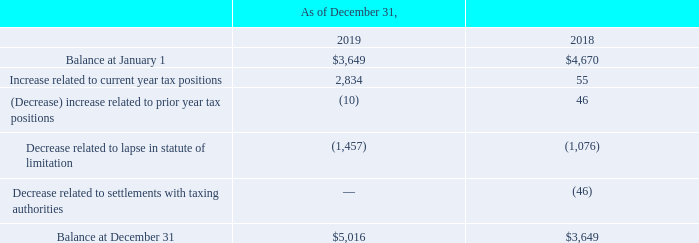NOTES TO CONSOLIDATED FINANCIAL STATEMENTS (in thousands, except for share and per share data)
Following the enactment of the 2017 Tax Cut and Jobs Act and the associated one-time transition tax, in general, repatriation of foreign earnings to the US can be completed with no incremental US Tax. However, there are limited other taxes that continue to apply such as foreign withholding and certain state taxes. The company records a deferred tax liability for the estimated foreign earnings and state tax cost associated with the undistributed foreign earnings that are not permanently reinvested.
The Tax Act also includes provisions for Global Intangible Low-Taxed Income (“GILTI”) wherein taxes on foreign income are imposed in excess of a deemed return on tangible assets of foreign corporations. We elected to recognize the tax on GILTI as an expense in the period the tax is incurred.
We recognize the financial statement benefit of a tax position when it is more-likely-than-not, based on its technical merits, that the position will be sustained upon examination. A tax position that meets the more-likely-than-not threshold is then measured to determine the amount of benefit to be recognized in the financial statements. As of December 31, 2019, we have approximately $5,016 of unrecognized tax benefits, which if recognized, would impact the effective tax rate. We do not anticipate any significant changes in our unrecognized tax benefits within the next 12 months.
A reconciliation of the beginning and ending unrecognized tax benefits is provided below:
Our continuing practice is to recognize interest and/or penalties related to unrecognized tax benefits as income tax expense. As of December 31, 2019, and 2018, $707 and $2,515, respectively, of interest and penalties were accrued.
We are subject to taxation in the U.S., various states, and in non-U.S. jurisdictions. Our U.S. income tax returns are primarily subject to examination from 2016 through 2018; however, U.S. tax authorities also have the ability to review prior tax years to the extent loss carryforwards and tax credit carryforwards are utilized. The open years for the non-U.S. tax returns range from 2008 through 2018 based on local statutes.
Which years does the table provide information for the reconciliation of the beginning and ending unrecognized tax benefits? 2019, 2018. What was the Increase related to current year tax positions in 2018?
Answer scale should be: thousand. 55. What was the amount of interest and penalties accrued that were related to unrecognized tax benefits as income tax expense in 2019?
Answer scale should be: thousand. 707. What was the change in the Increase related to current year tax positions between 2018 and 2019?
Answer scale should be: thousand. 2,834-55
Answer: 2779. What was the change in the balance at January 1 between 2018 and 2019?
Answer scale should be: thousand. 3,649-4,670
Answer: -1021. What was the percentage change in Balance at December 31 between 2018 and 2019?
Answer scale should be: percent. (5,016-3,649)/3,649
Answer: 37.46. 